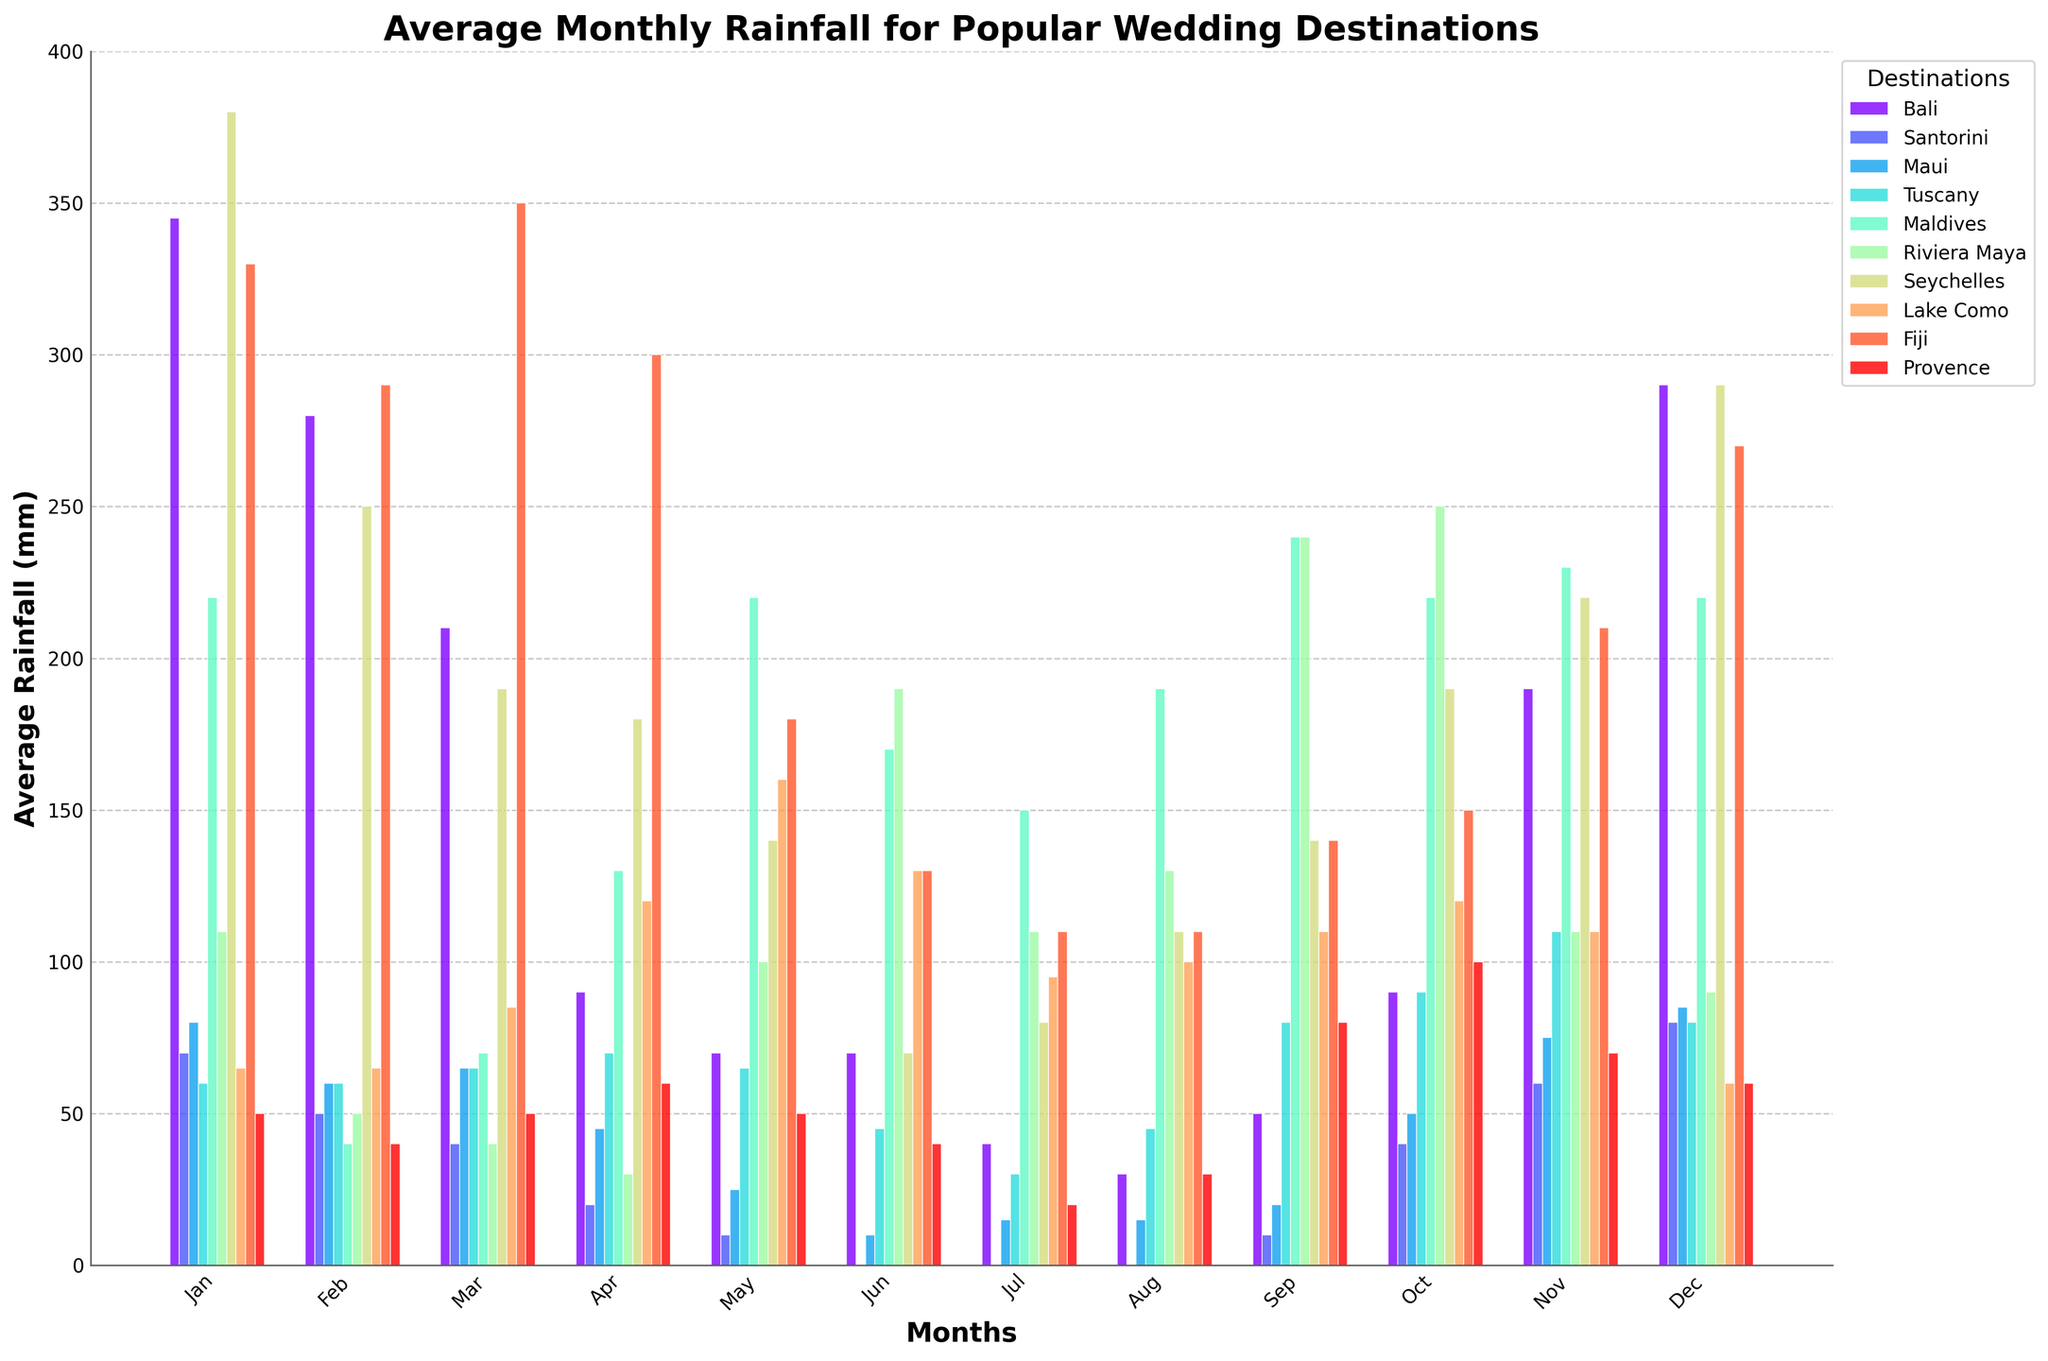Which destination has the highest average rainfall in January? Look at the bars for January and identify the highest one. Bali with 345 mm stands out.
Answer: Bali Which months have no rainfall in Santorini? Find the bars for Santorini and identify the months with a height of 0. The months with no rainfall are May, June, July, and August.
Answer: May, June, July, August What is the total rainfall in Fiji from June to August? Sum the rainfall amounts for Fiji in June, July, and August (130 + 110 + 110). The total is 350 mm.
Answer: 350 mm Which month has the highest rainfall in Maldives? Examine the heights of the bars for each month for Maldives and identify the highest one, which is November with 230 mm.
Answer: November Is there any month where Riviera Maya has more than twice the rainfall of Tuscany? Compare the rainfall in both locations for each month. For example, in October, Riviera Maya has 250 mm and Tuscany has 90 mm. 250 is more than twice 90.
Answer: Yes, October What’s the average rainfall in Maui between January and March? Compute the average of January, February, and March for Maui. Summing up: (80 + 60 + 65) / 3 gives 205 / 3 ≈ 68.3 mm.
Answer: 68.3 mm Which destination has the least rainfall in July? Compare the heights of the bars for July for all destinations. Santorini has the lowest with 0 mm.
Answer: Santorini What’s the difference in rainfall between Seychelles and Maldives in April? Subtract Seychelles’ April rainfall from Maldives' April rainfall (130 - 180 equals -50). Seychelles has 50 mm more in April.
Answer: 50 mm Which seasons (winter/spring/summer/autumn) have the lowest average rainfall overall in Provence? Calculate the average rainfall for each season in Provence. Winter (Jan-Mar, Dec): (50+40+50+60) / 4 = 50 mm, Spring (Apr-Jun): (60+50+40) / 3 ≈ 50 mm, Summer (Jul-Sep): (20+30+80) / 3 ≈ 43.3 mm, Autumn (Oct-Nov): (100+70) / 2 = 85 mm. Summer has the lowest.
Answer: Summer 